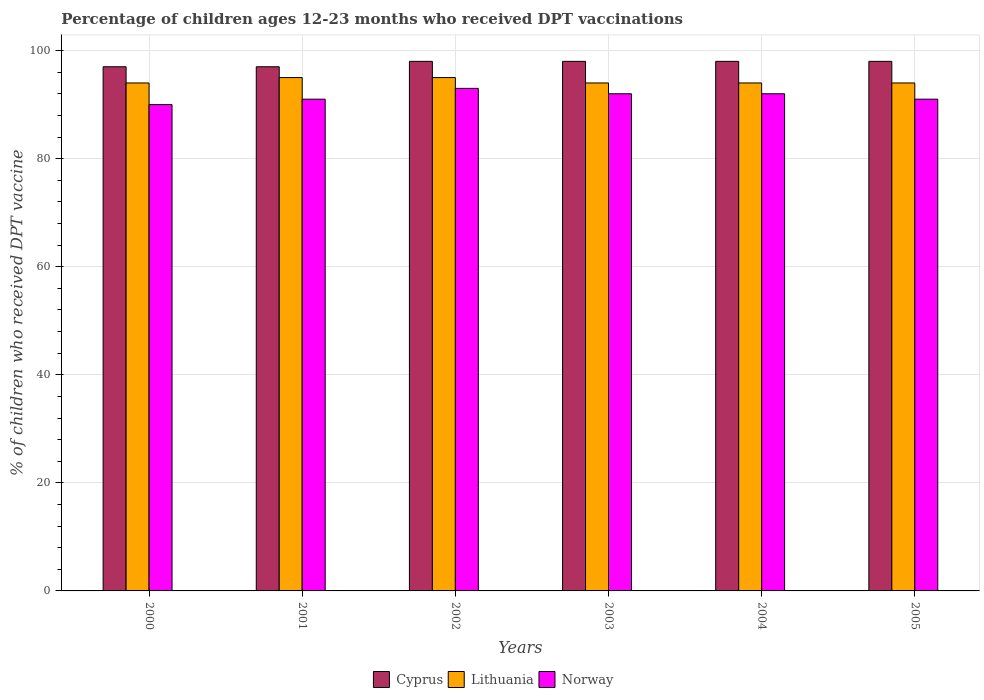How many different coloured bars are there?
Provide a short and direct response. 3. Are the number of bars per tick equal to the number of legend labels?
Keep it short and to the point. Yes. Are the number of bars on each tick of the X-axis equal?
Make the answer very short. Yes. How many bars are there on the 2nd tick from the left?
Provide a short and direct response. 3. How many bars are there on the 5th tick from the right?
Keep it short and to the point. 3. In how many cases, is the number of bars for a given year not equal to the number of legend labels?
Your response must be concise. 0. What is the percentage of children who received DPT vaccination in Norway in 2005?
Make the answer very short. 91. Across all years, what is the maximum percentage of children who received DPT vaccination in Norway?
Ensure brevity in your answer.  93. Across all years, what is the minimum percentage of children who received DPT vaccination in Cyprus?
Provide a succinct answer. 97. What is the total percentage of children who received DPT vaccination in Lithuania in the graph?
Provide a short and direct response. 566. What is the difference between the percentage of children who received DPT vaccination in Norway in 2000 and the percentage of children who received DPT vaccination in Lithuania in 2002?
Give a very brief answer. -5. What is the average percentage of children who received DPT vaccination in Cyprus per year?
Your answer should be very brief. 97.67. In how many years, is the percentage of children who received DPT vaccination in Cyprus greater than 12 %?
Offer a terse response. 6. Is the difference between the percentage of children who received DPT vaccination in Norway in 2000 and 2005 greater than the difference between the percentage of children who received DPT vaccination in Lithuania in 2000 and 2005?
Provide a short and direct response. No. What is the difference between the highest and the lowest percentage of children who received DPT vaccination in Cyprus?
Your answer should be compact. 1. In how many years, is the percentage of children who received DPT vaccination in Cyprus greater than the average percentage of children who received DPT vaccination in Cyprus taken over all years?
Give a very brief answer. 4. Is the sum of the percentage of children who received DPT vaccination in Lithuania in 2004 and 2005 greater than the maximum percentage of children who received DPT vaccination in Norway across all years?
Provide a short and direct response. Yes. What does the 3rd bar from the left in 2002 represents?
Provide a succinct answer. Norway. What does the 1st bar from the right in 2005 represents?
Make the answer very short. Norway. Is it the case that in every year, the sum of the percentage of children who received DPT vaccination in Lithuania and percentage of children who received DPT vaccination in Norway is greater than the percentage of children who received DPT vaccination in Cyprus?
Make the answer very short. Yes. Are all the bars in the graph horizontal?
Provide a short and direct response. No. How many years are there in the graph?
Provide a succinct answer. 6. Are the values on the major ticks of Y-axis written in scientific E-notation?
Ensure brevity in your answer.  No. Does the graph contain grids?
Make the answer very short. Yes. Where does the legend appear in the graph?
Your answer should be compact. Bottom center. How are the legend labels stacked?
Ensure brevity in your answer.  Horizontal. What is the title of the graph?
Offer a very short reply. Percentage of children ages 12-23 months who received DPT vaccinations. What is the label or title of the Y-axis?
Your response must be concise. % of children who received DPT vaccine. What is the % of children who received DPT vaccine of Cyprus in 2000?
Keep it short and to the point. 97. What is the % of children who received DPT vaccine of Lithuania in 2000?
Provide a succinct answer. 94. What is the % of children who received DPT vaccine of Norway in 2000?
Offer a very short reply. 90. What is the % of children who received DPT vaccine in Cyprus in 2001?
Give a very brief answer. 97. What is the % of children who received DPT vaccine of Norway in 2001?
Give a very brief answer. 91. What is the % of children who received DPT vaccine of Cyprus in 2002?
Make the answer very short. 98. What is the % of children who received DPT vaccine in Lithuania in 2002?
Provide a short and direct response. 95. What is the % of children who received DPT vaccine of Norway in 2002?
Give a very brief answer. 93. What is the % of children who received DPT vaccine in Lithuania in 2003?
Offer a very short reply. 94. What is the % of children who received DPT vaccine in Norway in 2003?
Ensure brevity in your answer.  92. What is the % of children who received DPT vaccine in Lithuania in 2004?
Give a very brief answer. 94. What is the % of children who received DPT vaccine in Norway in 2004?
Give a very brief answer. 92. What is the % of children who received DPT vaccine in Lithuania in 2005?
Ensure brevity in your answer.  94. What is the % of children who received DPT vaccine in Norway in 2005?
Keep it short and to the point. 91. Across all years, what is the maximum % of children who received DPT vaccine of Cyprus?
Your response must be concise. 98. Across all years, what is the maximum % of children who received DPT vaccine in Lithuania?
Ensure brevity in your answer.  95. Across all years, what is the maximum % of children who received DPT vaccine in Norway?
Ensure brevity in your answer.  93. Across all years, what is the minimum % of children who received DPT vaccine of Cyprus?
Your answer should be compact. 97. Across all years, what is the minimum % of children who received DPT vaccine of Lithuania?
Keep it short and to the point. 94. What is the total % of children who received DPT vaccine in Cyprus in the graph?
Make the answer very short. 586. What is the total % of children who received DPT vaccine in Lithuania in the graph?
Your answer should be compact. 566. What is the total % of children who received DPT vaccine in Norway in the graph?
Offer a terse response. 549. What is the difference between the % of children who received DPT vaccine in Cyprus in 2000 and that in 2001?
Make the answer very short. 0. What is the difference between the % of children who received DPT vaccine of Norway in 2000 and that in 2001?
Offer a terse response. -1. What is the difference between the % of children who received DPT vaccine of Cyprus in 2000 and that in 2002?
Offer a very short reply. -1. What is the difference between the % of children who received DPT vaccine of Cyprus in 2000 and that in 2003?
Your answer should be compact. -1. What is the difference between the % of children who received DPT vaccine in Norway in 2000 and that in 2003?
Your answer should be very brief. -2. What is the difference between the % of children who received DPT vaccine in Cyprus in 2000 and that in 2004?
Keep it short and to the point. -1. What is the difference between the % of children who received DPT vaccine in Lithuania in 2000 and that in 2004?
Give a very brief answer. 0. What is the difference between the % of children who received DPT vaccine of Norway in 2000 and that in 2004?
Ensure brevity in your answer.  -2. What is the difference between the % of children who received DPT vaccine in Cyprus in 2000 and that in 2005?
Make the answer very short. -1. What is the difference between the % of children who received DPT vaccine in Norway in 2001 and that in 2002?
Your response must be concise. -2. What is the difference between the % of children who received DPT vaccine in Norway in 2001 and that in 2003?
Offer a very short reply. -1. What is the difference between the % of children who received DPT vaccine in Norway in 2001 and that in 2004?
Make the answer very short. -1. What is the difference between the % of children who received DPT vaccine in Norway in 2001 and that in 2005?
Provide a short and direct response. 0. What is the difference between the % of children who received DPT vaccine of Cyprus in 2002 and that in 2003?
Keep it short and to the point. 0. What is the difference between the % of children who received DPT vaccine in Lithuania in 2002 and that in 2003?
Give a very brief answer. 1. What is the difference between the % of children who received DPT vaccine of Norway in 2002 and that in 2003?
Ensure brevity in your answer.  1. What is the difference between the % of children who received DPT vaccine of Cyprus in 2002 and that in 2004?
Offer a terse response. 0. What is the difference between the % of children who received DPT vaccine in Lithuania in 2002 and that in 2004?
Ensure brevity in your answer.  1. What is the difference between the % of children who received DPT vaccine in Norway in 2002 and that in 2005?
Give a very brief answer. 2. What is the difference between the % of children who received DPT vaccine of Lithuania in 2003 and that in 2004?
Your response must be concise. 0. What is the difference between the % of children who received DPT vaccine in Norway in 2003 and that in 2004?
Your response must be concise. 0. What is the difference between the % of children who received DPT vaccine in Cyprus in 2000 and the % of children who received DPT vaccine in Lithuania in 2001?
Offer a terse response. 2. What is the difference between the % of children who received DPT vaccine in Lithuania in 2000 and the % of children who received DPT vaccine in Norway in 2001?
Provide a short and direct response. 3. What is the difference between the % of children who received DPT vaccine in Cyprus in 2000 and the % of children who received DPT vaccine in Lithuania in 2002?
Ensure brevity in your answer.  2. What is the difference between the % of children who received DPT vaccine of Cyprus in 2000 and the % of children who received DPT vaccine of Lithuania in 2003?
Offer a terse response. 3. What is the difference between the % of children who received DPT vaccine of Cyprus in 2000 and the % of children who received DPT vaccine of Lithuania in 2004?
Offer a very short reply. 3. What is the difference between the % of children who received DPT vaccine in Cyprus in 2000 and the % of children who received DPT vaccine in Lithuania in 2005?
Offer a terse response. 3. What is the difference between the % of children who received DPT vaccine of Cyprus in 2001 and the % of children who received DPT vaccine of Lithuania in 2002?
Make the answer very short. 2. What is the difference between the % of children who received DPT vaccine in Lithuania in 2001 and the % of children who received DPT vaccine in Norway in 2002?
Offer a terse response. 2. What is the difference between the % of children who received DPT vaccine in Cyprus in 2001 and the % of children who received DPT vaccine in Lithuania in 2003?
Ensure brevity in your answer.  3. What is the difference between the % of children who received DPT vaccine of Cyprus in 2001 and the % of children who received DPT vaccine of Norway in 2003?
Your answer should be compact. 5. What is the difference between the % of children who received DPT vaccine in Cyprus in 2001 and the % of children who received DPT vaccine in Norway in 2004?
Your answer should be compact. 5. What is the difference between the % of children who received DPT vaccine in Lithuania in 2001 and the % of children who received DPT vaccine in Norway in 2004?
Keep it short and to the point. 3. What is the difference between the % of children who received DPT vaccine of Cyprus in 2001 and the % of children who received DPT vaccine of Lithuania in 2005?
Your answer should be very brief. 3. What is the difference between the % of children who received DPT vaccine in Cyprus in 2001 and the % of children who received DPT vaccine in Norway in 2005?
Keep it short and to the point. 6. What is the difference between the % of children who received DPT vaccine of Lithuania in 2002 and the % of children who received DPT vaccine of Norway in 2003?
Your answer should be compact. 3. What is the difference between the % of children who received DPT vaccine in Cyprus in 2002 and the % of children who received DPT vaccine in Lithuania in 2004?
Your answer should be compact. 4. What is the difference between the % of children who received DPT vaccine of Cyprus in 2002 and the % of children who received DPT vaccine of Norway in 2004?
Offer a terse response. 6. What is the difference between the % of children who received DPT vaccine in Lithuania in 2002 and the % of children who received DPT vaccine in Norway in 2004?
Offer a terse response. 3. What is the difference between the % of children who received DPT vaccine in Cyprus in 2002 and the % of children who received DPT vaccine in Norway in 2005?
Offer a very short reply. 7. What is the difference between the % of children who received DPT vaccine in Lithuania in 2002 and the % of children who received DPT vaccine in Norway in 2005?
Your answer should be compact. 4. What is the difference between the % of children who received DPT vaccine in Cyprus in 2004 and the % of children who received DPT vaccine in Lithuania in 2005?
Provide a succinct answer. 4. What is the difference between the % of children who received DPT vaccine of Cyprus in 2004 and the % of children who received DPT vaccine of Norway in 2005?
Provide a short and direct response. 7. What is the average % of children who received DPT vaccine of Cyprus per year?
Ensure brevity in your answer.  97.67. What is the average % of children who received DPT vaccine in Lithuania per year?
Provide a succinct answer. 94.33. What is the average % of children who received DPT vaccine of Norway per year?
Provide a succinct answer. 91.5. In the year 2000, what is the difference between the % of children who received DPT vaccine in Cyprus and % of children who received DPT vaccine in Lithuania?
Ensure brevity in your answer.  3. In the year 2000, what is the difference between the % of children who received DPT vaccine of Lithuania and % of children who received DPT vaccine of Norway?
Provide a succinct answer. 4. In the year 2001, what is the difference between the % of children who received DPT vaccine in Cyprus and % of children who received DPT vaccine in Norway?
Your answer should be compact. 6. In the year 2002, what is the difference between the % of children who received DPT vaccine of Cyprus and % of children who received DPT vaccine of Lithuania?
Your answer should be compact. 3. In the year 2003, what is the difference between the % of children who received DPT vaccine in Cyprus and % of children who received DPT vaccine in Norway?
Make the answer very short. 6. In the year 2004, what is the difference between the % of children who received DPT vaccine of Cyprus and % of children who received DPT vaccine of Norway?
Ensure brevity in your answer.  6. In the year 2004, what is the difference between the % of children who received DPT vaccine of Lithuania and % of children who received DPT vaccine of Norway?
Provide a short and direct response. 2. In the year 2005, what is the difference between the % of children who received DPT vaccine in Cyprus and % of children who received DPT vaccine in Lithuania?
Your response must be concise. 4. What is the ratio of the % of children who received DPT vaccine of Cyprus in 2000 to that in 2001?
Give a very brief answer. 1. What is the ratio of the % of children who received DPT vaccine of Lithuania in 2000 to that in 2001?
Keep it short and to the point. 0.99. What is the ratio of the % of children who received DPT vaccine in Norway in 2000 to that in 2001?
Make the answer very short. 0.99. What is the ratio of the % of children who received DPT vaccine in Cyprus in 2000 to that in 2003?
Provide a short and direct response. 0.99. What is the ratio of the % of children who received DPT vaccine in Norway in 2000 to that in 2003?
Ensure brevity in your answer.  0.98. What is the ratio of the % of children who received DPT vaccine of Cyprus in 2000 to that in 2004?
Keep it short and to the point. 0.99. What is the ratio of the % of children who received DPT vaccine in Lithuania in 2000 to that in 2004?
Ensure brevity in your answer.  1. What is the ratio of the % of children who received DPT vaccine in Norway in 2000 to that in 2004?
Provide a succinct answer. 0.98. What is the ratio of the % of children who received DPT vaccine in Cyprus in 2000 to that in 2005?
Make the answer very short. 0.99. What is the ratio of the % of children who received DPT vaccine in Norway in 2000 to that in 2005?
Offer a very short reply. 0.99. What is the ratio of the % of children who received DPT vaccine in Norway in 2001 to that in 2002?
Ensure brevity in your answer.  0.98. What is the ratio of the % of children who received DPT vaccine in Lithuania in 2001 to that in 2003?
Keep it short and to the point. 1.01. What is the ratio of the % of children who received DPT vaccine of Lithuania in 2001 to that in 2004?
Offer a very short reply. 1.01. What is the ratio of the % of children who received DPT vaccine of Lithuania in 2001 to that in 2005?
Provide a short and direct response. 1.01. What is the ratio of the % of children who received DPT vaccine in Cyprus in 2002 to that in 2003?
Your answer should be compact. 1. What is the ratio of the % of children who received DPT vaccine of Lithuania in 2002 to that in 2003?
Offer a very short reply. 1.01. What is the ratio of the % of children who received DPT vaccine in Norway in 2002 to that in 2003?
Keep it short and to the point. 1.01. What is the ratio of the % of children who received DPT vaccine in Lithuania in 2002 to that in 2004?
Offer a very short reply. 1.01. What is the ratio of the % of children who received DPT vaccine of Norway in 2002 to that in 2004?
Your answer should be very brief. 1.01. What is the ratio of the % of children who received DPT vaccine in Lithuania in 2002 to that in 2005?
Provide a succinct answer. 1.01. What is the ratio of the % of children who received DPT vaccine in Cyprus in 2003 to that in 2005?
Give a very brief answer. 1. What is the ratio of the % of children who received DPT vaccine in Norway in 2003 to that in 2005?
Provide a short and direct response. 1.01. What is the ratio of the % of children who received DPT vaccine of Cyprus in 2004 to that in 2005?
Provide a short and direct response. 1. What is the ratio of the % of children who received DPT vaccine in Lithuania in 2004 to that in 2005?
Your response must be concise. 1. What is the difference between the highest and the second highest % of children who received DPT vaccine in Norway?
Provide a succinct answer. 1. What is the difference between the highest and the lowest % of children who received DPT vaccine of Norway?
Keep it short and to the point. 3. 